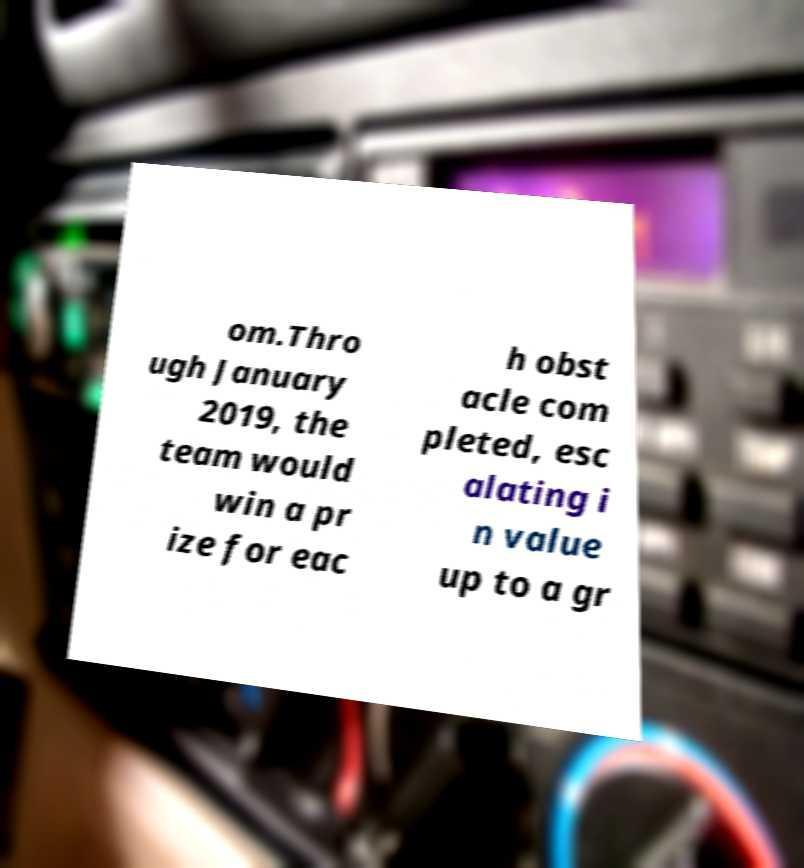Could you assist in decoding the text presented in this image and type it out clearly? om.Thro ugh January 2019, the team would win a pr ize for eac h obst acle com pleted, esc alating i n value up to a gr 